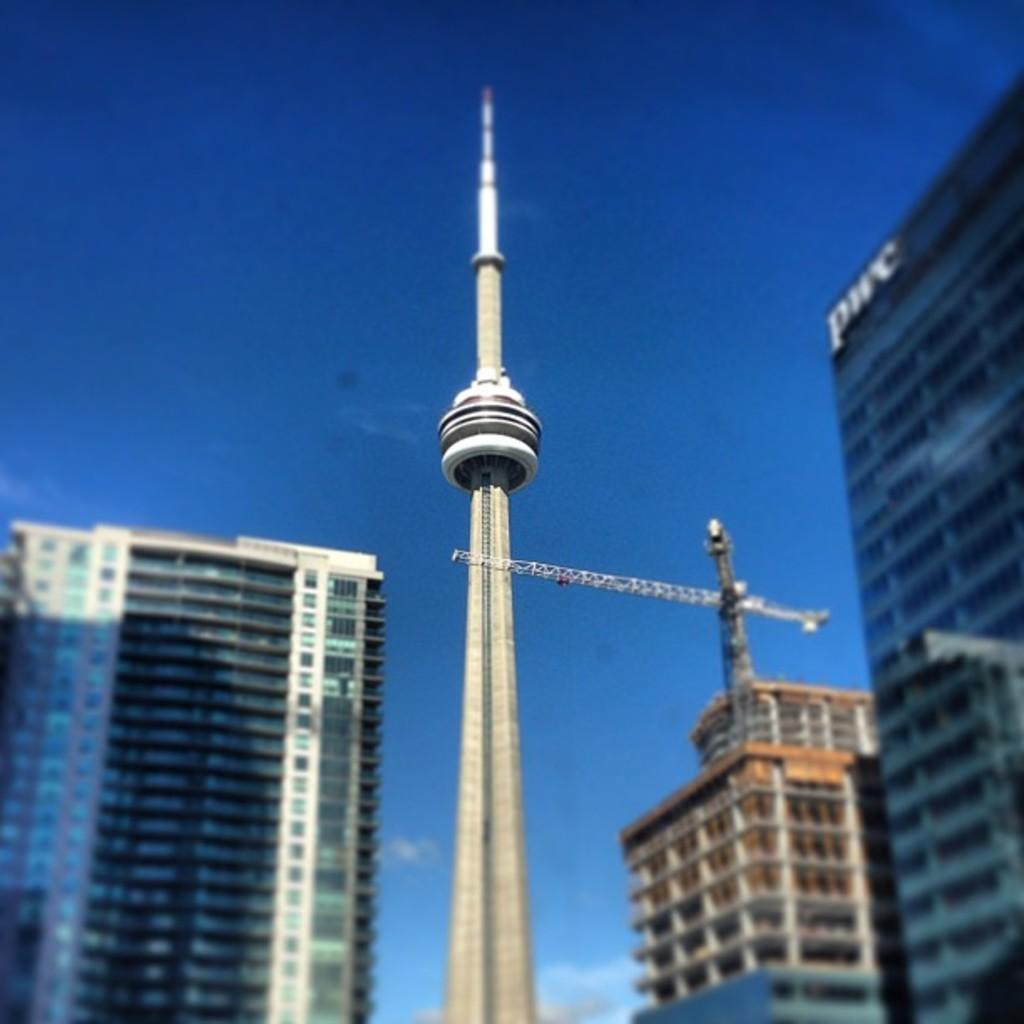What is the main structure in the middle of the image? There is a big tower in the middle of the image. What other structures can be seen in the image? There are buildings in the image. What color is the sky at the top of the image? The sky is blue at the top of the image. How much does the tree weigh in the image? There is no tree present in the image, so its weight cannot be determined. 